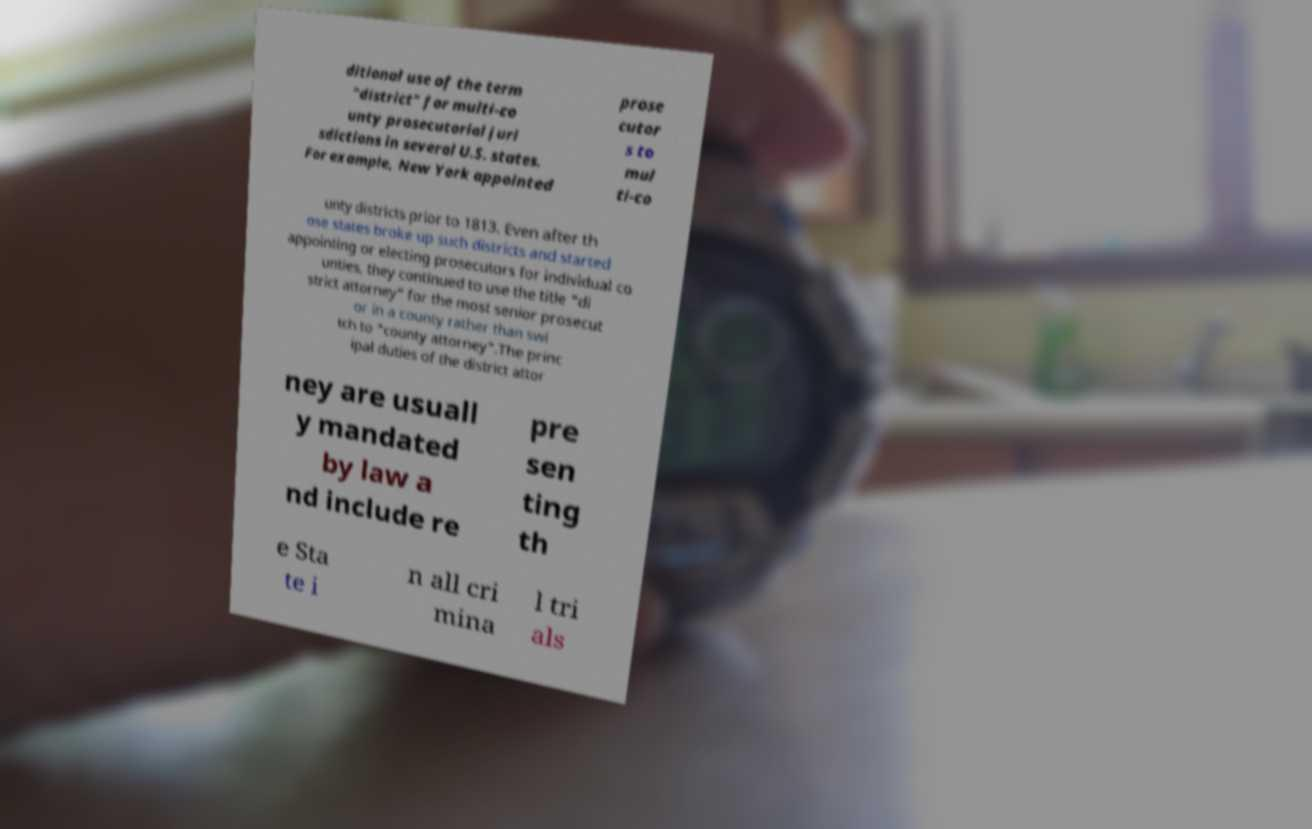There's text embedded in this image that I need extracted. Can you transcribe it verbatim? ditional use of the term "district" for multi-co unty prosecutorial juri sdictions in several U.S. states. For example, New York appointed prose cutor s to mul ti-co unty districts prior to 1813. Even after th ose states broke up such districts and started appointing or electing prosecutors for individual co unties, they continued to use the title "di strict attorney" for the most senior prosecut or in a county rather than swi tch to "county attorney".The princ ipal duties of the district attor ney are usuall y mandated by law a nd include re pre sen ting th e Sta te i n all cri mina l tri als 